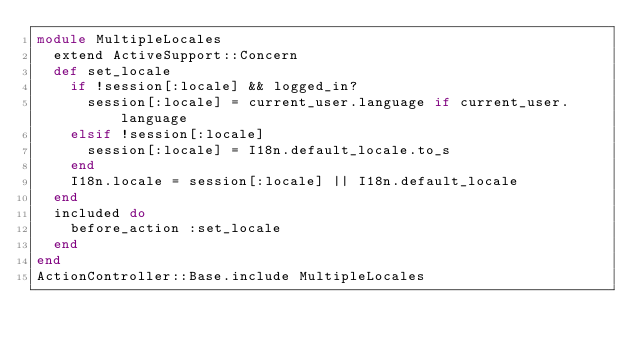<code> <loc_0><loc_0><loc_500><loc_500><_Ruby_>module MultipleLocales
  extend ActiveSupport::Concern
  def set_locale
    if !session[:locale] && logged_in?
      session[:locale] = current_user.language if current_user.language
    elsif !session[:locale]
      session[:locale] = I18n.default_locale.to_s
    end
    I18n.locale = session[:locale] || I18n.default_locale
  end
  included do
    before_action :set_locale
  end
end
ActionController::Base.include MultipleLocales
</code> 